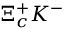<formula> <loc_0><loc_0><loc_500><loc_500>\Xi _ { c } ^ { + } K ^ { - }</formula> 